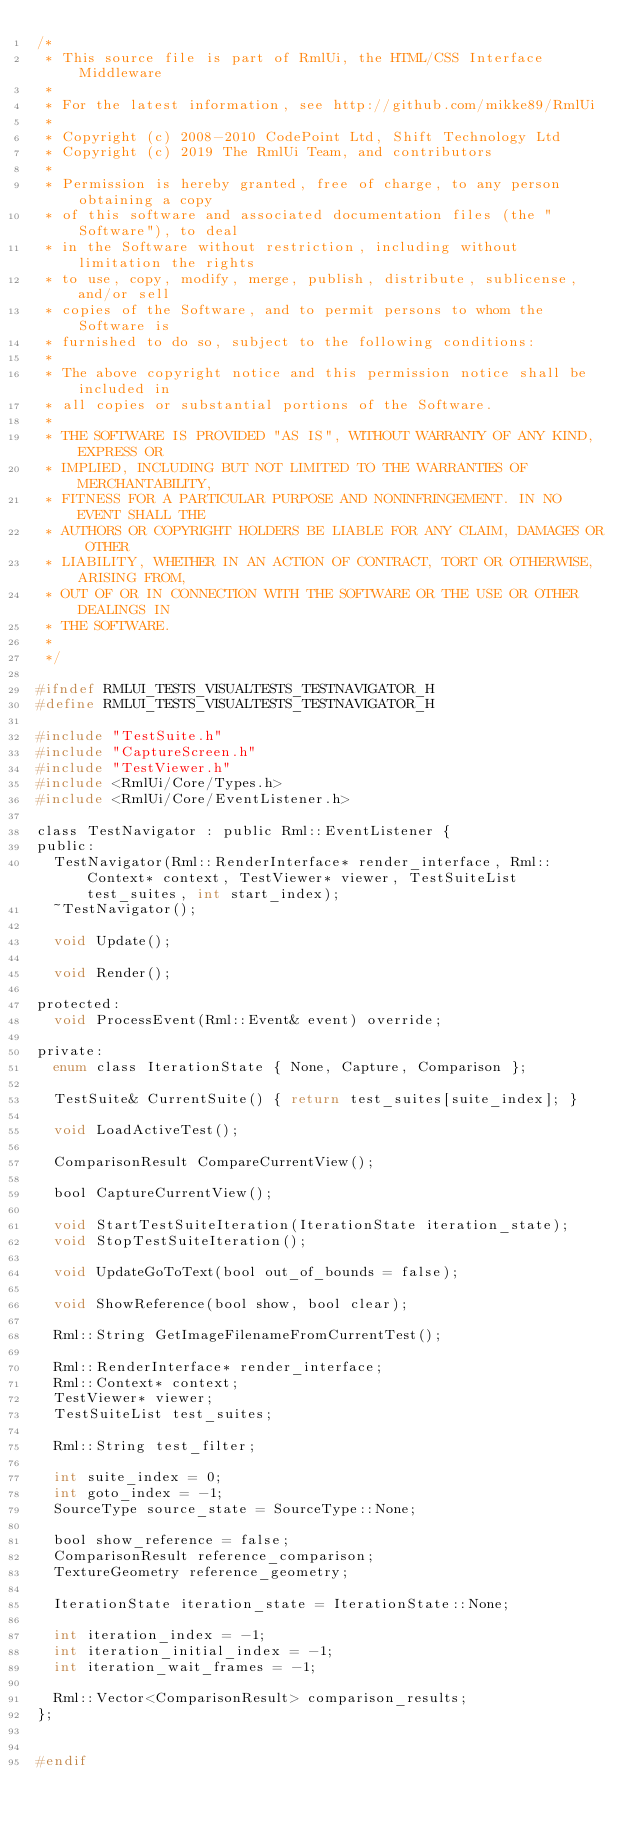Convert code to text. <code><loc_0><loc_0><loc_500><loc_500><_C_>/*
 * This source file is part of RmlUi, the HTML/CSS Interface Middleware
 *
 * For the latest information, see http://github.com/mikke89/RmlUi
 *
 * Copyright (c) 2008-2010 CodePoint Ltd, Shift Technology Ltd
 * Copyright (c) 2019 The RmlUi Team, and contributors
 *
 * Permission is hereby granted, free of charge, to any person obtaining a copy
 * of this software and associated documentation files (the "Software"), to deal
 * in the Software without restriction, including without limitation the rights
 * to use, copy, modify, merge, publish, distribute, sublicense, and/or sell
 * copies of the Software, and to permit persons to whom the Software is
 * furnished to do so, subject to the following conditions:
 *
 * The above copyright notice and this permission notice shall be included in
 * all copies or substantial portions of the Software.
 *
 * THE SOFTWARE IS PROVIDED "AS IS", WITHOUT WARRANTY OF ANY KIND, EXPRESS OR
 * IMPLIED, INCLUDING BUT NOT LIMITED TO THE WARRANTIES OF MERCHANTABILITY,
 * FITNESS FOR A PARTICULAR PURPOSE AND NONINFRINGEMENT. IN NO EVENT SHALL THE
 * AUTHORS OR COPYRIGHT HOLDERS BE LIABLE FOR ANY CLAIM, DAMAGES OR OTHER
 * LIABILITY, WHETHER IN AN ACTION OF CONTRACT, TORT OR OTHERWISE, ARISING FROM,
 * OUT OF OR IN CONNECTION WITH THE SOFTWARE OR THE USE OR OTHER DEALINGS IN
 * THE SOFTWARE.
 *
 */

#ifndef RMLUI_TESTS_VISUALTESTS_TESTNAVIGATOR_H
#define RMLUI_TESTS_VISUALTESTS_TESTNAVIGATOR_H

#include "TestSuite.h"
#include "CaptureScreen.h"
#include "TestViewer.h"
#include <RmlUi/Core/Types.h>
#include <RmlUi/Core/EventListener.h>

class TestNavigator : public Rml::EventListener {
public:
	TestNavigator(Rml::RenderInterface* render_interface, Rml::Context* context, TestViewer* viewer, TestSuiteList test_suites, int start_index);
	~TestNavigator();

	void Update();

	void Render();

protected:
	void ProcessEvent(Rml::Event& event) override;

private:
	enum class IterationState { None, Capture, Comparison };

	TestSuite& CurrentSuite() { return test_suites[suite_index]; }

	void LoadActiveTest();

	ComparisonResult CompareCurrentView();

	bool CaptureCurrentView();

	void StartTestSuiteIteration(IterationState iteration_state);
	void StopTestSuiteIteration();

	void UpdateGoToText(bool out_of_bounds = false);

	void ShowReference(bool show, bool clear);

	Rml::String GetImageFilenameFromCurrentTest();

	Rml::RenderInterface* render_interface;
	Rml::Context* context;
	TestViewer* viewer;
	TestSuiteList test_suites;

	Rml::String test_filter;

	int suite_index = 0;
	int goto_index = -1;
	SourceType source_state = SourceType::None;

	bool show_reference = false;
	ComparisonResult reference_comparison;
	TextureGeometry reference_geometry;

	IterationState iteration_state = IterationState::None;

	int iteration_index = -1;
	int iteration_initial_index = -1;
	int iteration_wait_frames = -1;

	Rml::Vector<ComparisonResult> comparison_results;
};


#endif
</code> 